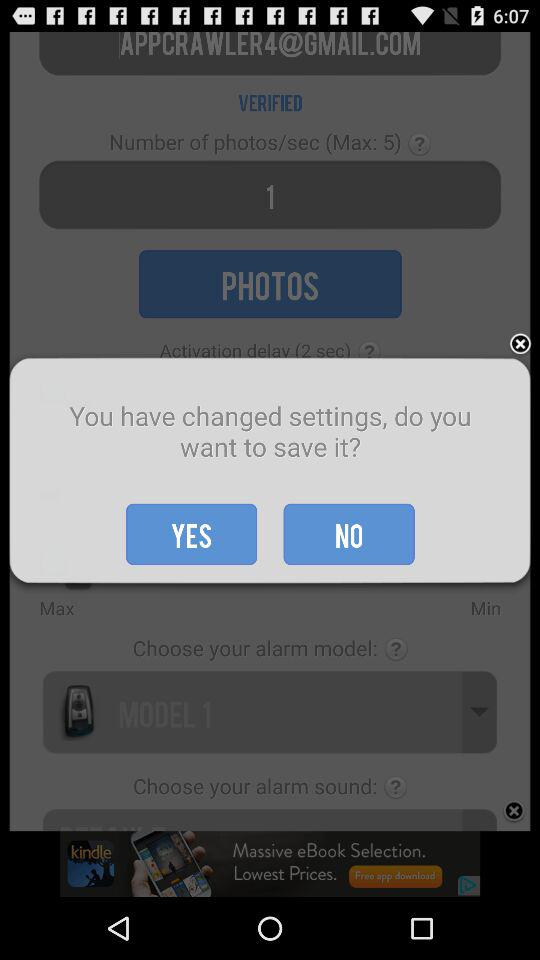How many photos are required per second? There is 1 photo required per second. 